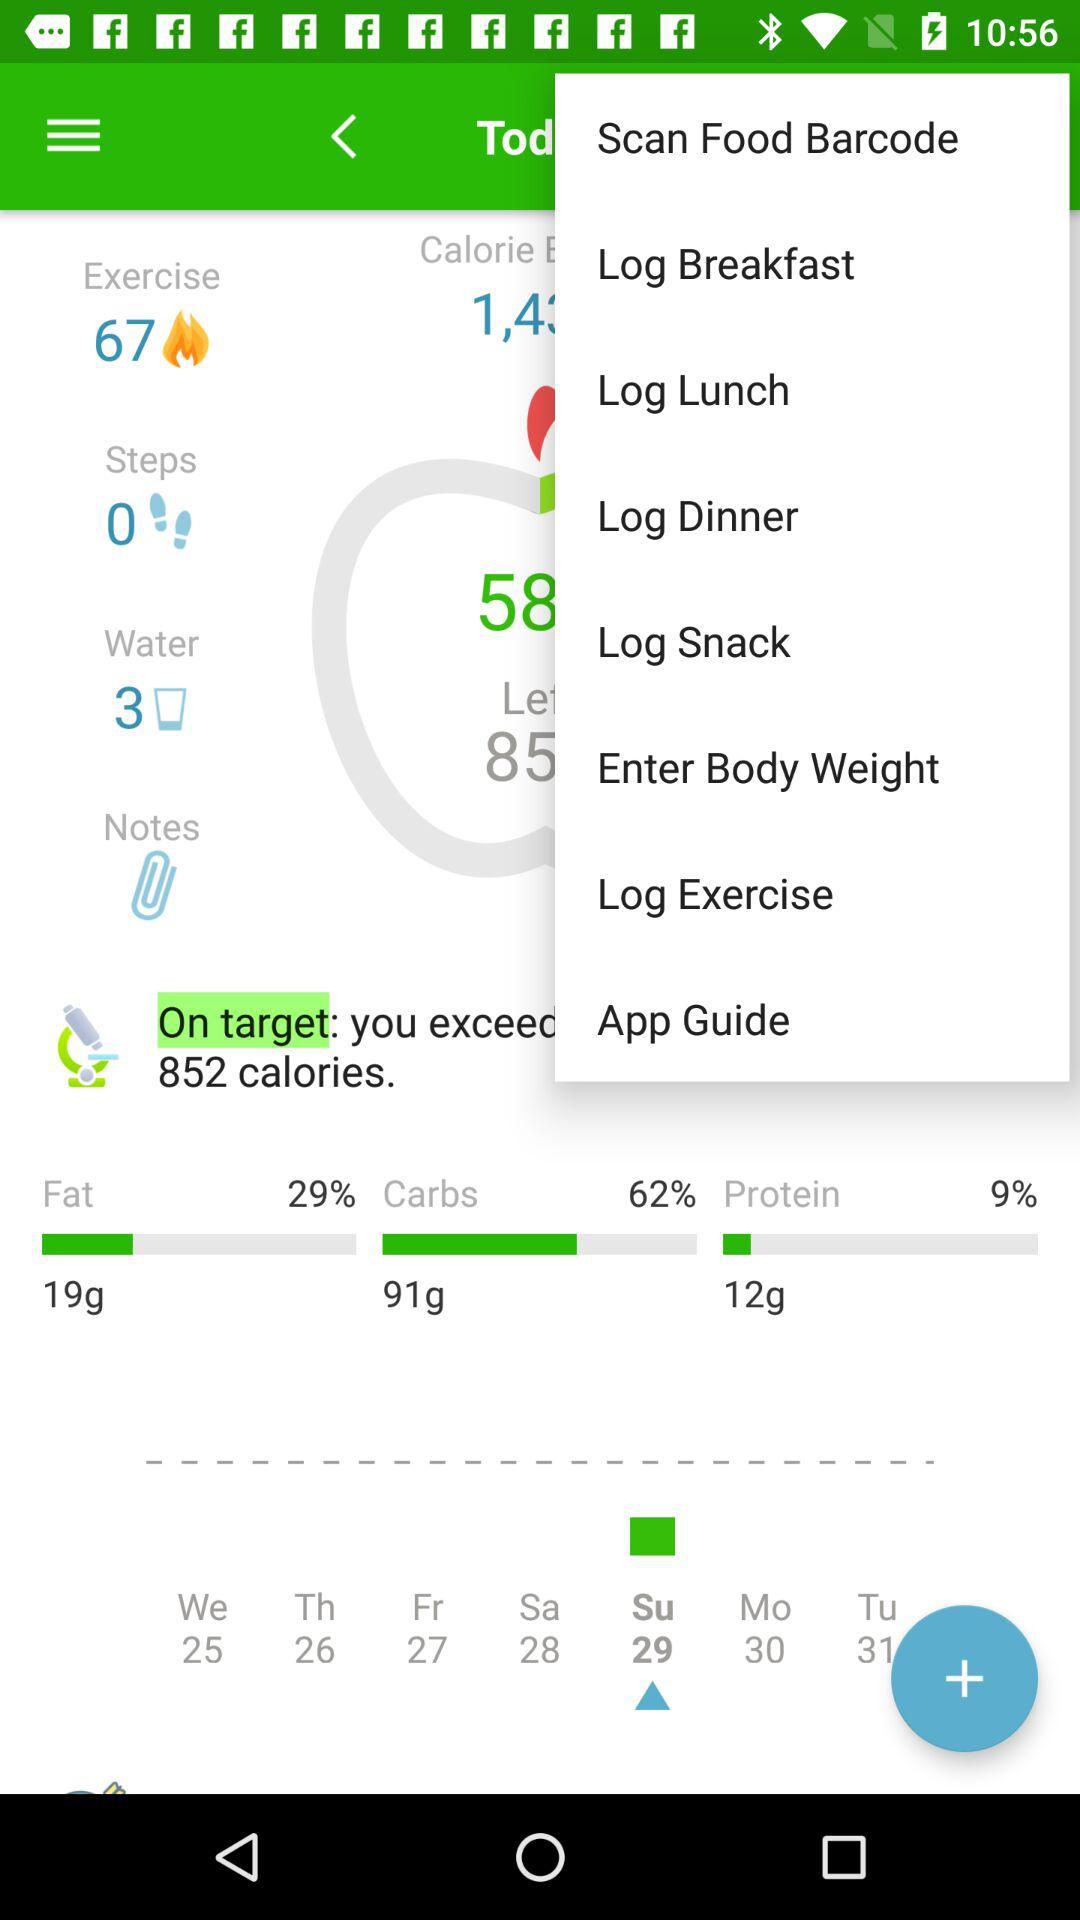How many exercises are there? There are 67 exercises. 